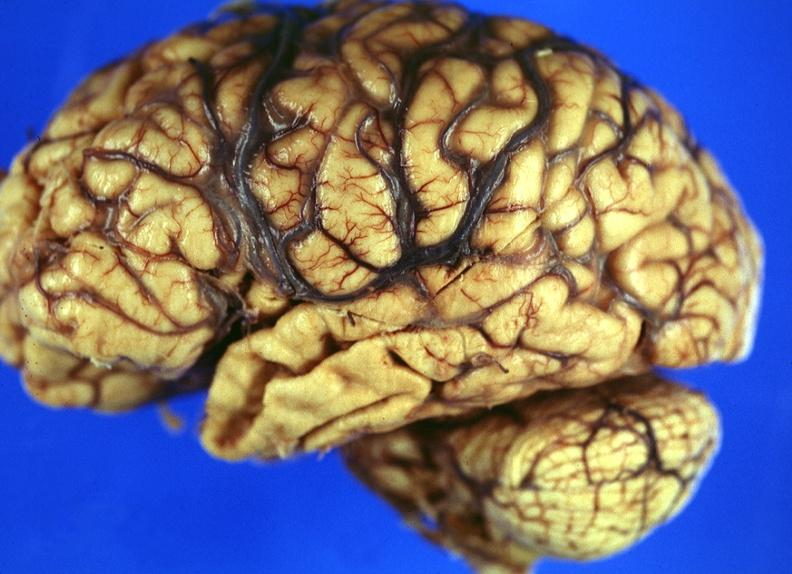s metastatic carcinoma breast present?
Answer the question using a single word or phrase. No 